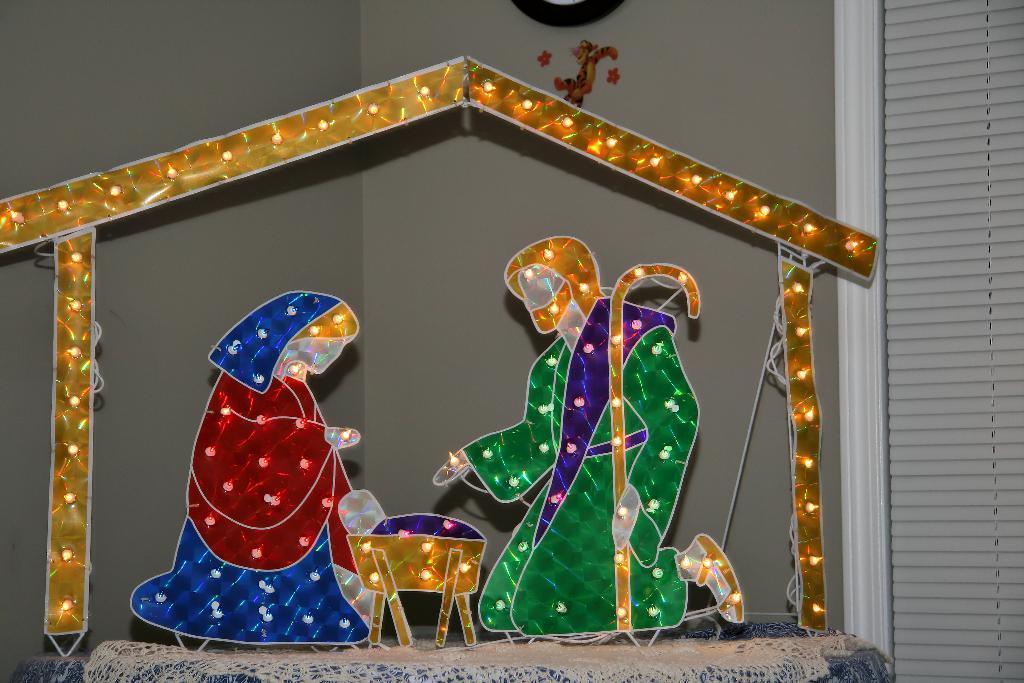In one or two sentences, can you explain what this image depicts? In this image, we can see a decorative object on the surface. We can also see a window blind on the right. In the background, we can see the wall with some objects. 